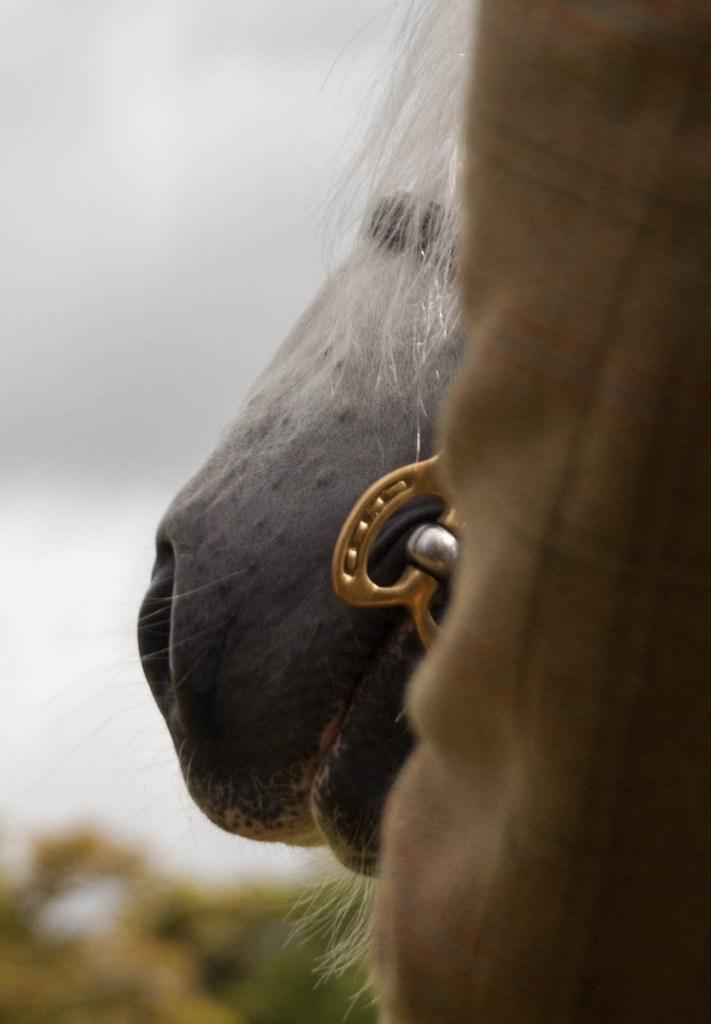In one or two sentences, can you explain what this image depicts? In this picture we can see an animal and a cloth. Behind the animal there is the blurred background. 